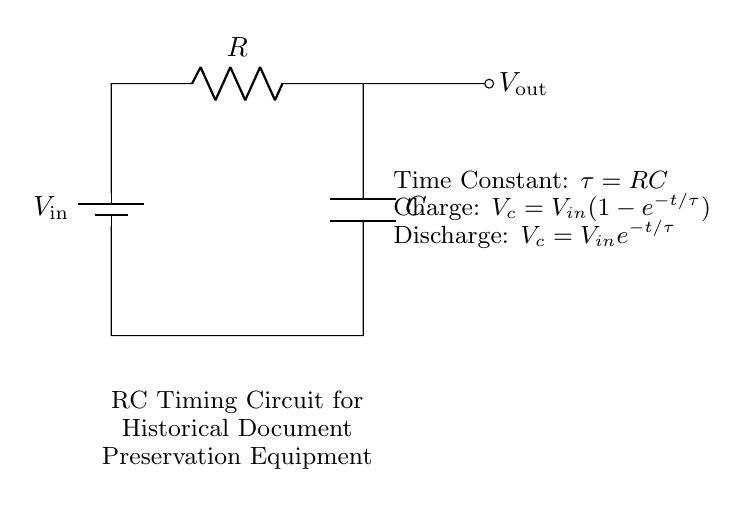What is the name of this circuit? The circuit is referred to as an "RC Timing Circuit," which is indicated in the diagram's description.
Answer: RC Timing Circuit What components are present in this circuit? The circuit consists of a resistor, a capacitor, and a battery (voltage source). Each of these components can be identified in the circuit diagram.
Answer: Resistor, Capacitor, Battery What is the time constant of the circuit? The time constant is denoted by the symbol "tau" and is defined as the product of resistance and capacitance, expressed as "tau = RC" in the diagram.
Answer: RC What happens to the voltage across the capacitor during charging? During charging, the voltage across the capacitor follows the formula "V_c = V_in(1-e^{-t/\tau})", which indicates that it increases over time until it approaches the input voltage.
Answer: Increases What happens to the voltage across the capacitor during discharging? During discharging, the voltage across the capacitor decreases according to the formula "V_c = V_in e^{-t/\tau}", indicating an exponential decay over time from the initial voltage.
Answer: Decreases At what time does the capacitor reach approximately 63.2 percent of the supply voltage during charging? The capacitor reaches approximately 63.2 percent of the supply voltage (input voltage) after one time constant, "tau". This is derived from the charging formula for the capacitor.
Answer: Tau Is the output voltage influenced by the resistor and capacitor values in this circuit? Yes, the output voltage is significantly influenced by the values of the resistor and capacitor because they determine the time constant and the charging/discharging rates, which affect how quickly the output voltage rises and falls.
Answer: Yes 